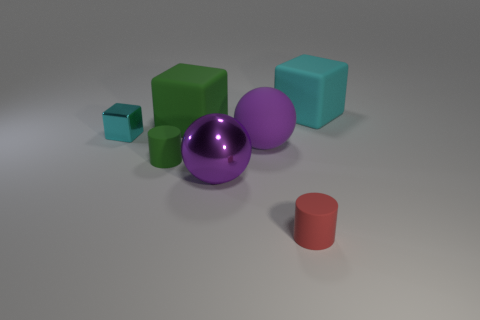How many other things are there of the same color as the shiny sphere?
Give a very brief answer. 1. What is the big green object made of?
Offer a terse response. Rubber. Do the cyan object that is on the left side of the red rubber cylinder and the big metallic ball have the same size?
Provide a succinct answer. No. Is there anything else that is the same size as the shiny block?
Offer a very short reply. Yes. There is a metal object that is the same shape as the big green rubber object; what is its size?
Your answer should be compact. Small. Are there an equal number of big green rubber objects that are left of the green block and large spheres to the left of the rubber sphere?
Offer a very short reply. No. What is the size of the cyan rubber cube that is behind the big purple rubber object?
Keep it short and to the point. Large. Do the big metallic thing and the big rubber sphere have the same color?
Provide a short and direct response. Yes. Is there any other thing that has the same shape as the large purple rubber thing?
Make the answer very short. Yes. What material is the big object that is the same color as the rubber sphere?
Give a very brief answer. Metal. 